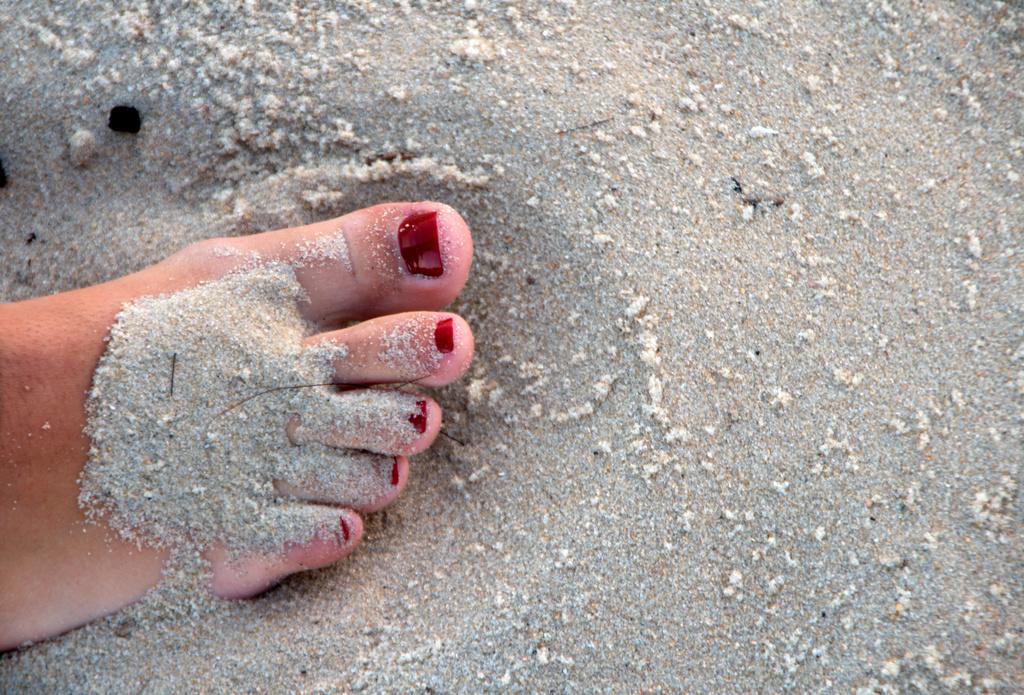Could you give a brief overview of what you see in this image? In this image I can see a person leg and I can also see the sand which is in gray color. 